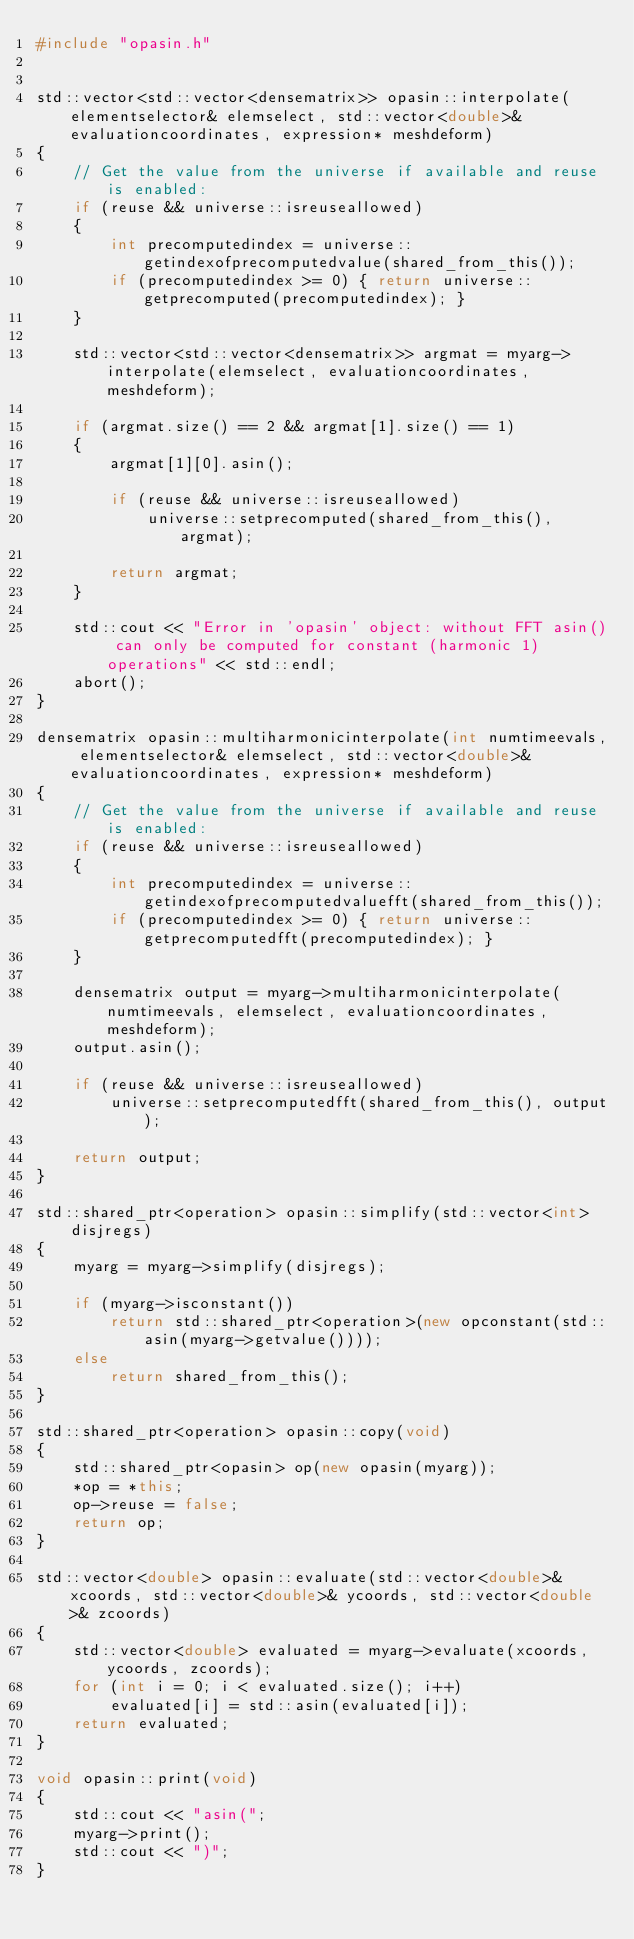Convert code to text. <code><loc_0><loc_0><loc_500><loc_500><_C++_>#include "opasin.h"


std::vector<std::vector<densematrix>> opasin::interpolate(elementselector& elemselect, std::vector<double>& evaluationcoordinates, expression* meshdeform)
{
    // Get the value from the universe if available and reuse is enabled:
    if (reuse && universe::isreuseallowed)
    {
        int precomputedindex = universe::getindexofprecomputedvalue(shared_from_this());
        if (precomputedindex >= 0) { return universe::getprecomputed(precomputedindex); }
    }
    
    std::vector<std::vector<densematrix>> argmat = myarg->interpolate(elemselect, evaluationcoordinates, meshdeform);
    
    if (argmat.size() == 2 && argmat[1].size() == 1)
    {
        argmat[1][0].asin();
        
        if (reuse && universe::isreuseallowed)
            universe::setprecomputed(shared_from_this(), argmat);
        
        return argmat;
    }

    std::cout << "Error in 'opasin' object: without FFT asin() can only be computed for constant (harmonic 1) operations" << std::endl;
    abort();
}

densematrix opasin::multiharmonicinterpolate(int numtimeevals, elementselector& elemselect, std::vector<double>& evaluationcoordinates, expression* meshdeform)
{
    // Get the value from the universe if available and reuse is enabled:
    if (reuse && universe::isreuseallowed)
    {
        int precomputedindex = universe::getindexofprecomputedvaluefft(shared_from_this());
        if (precomputedindex >= 0) { return universe::getprecomputedfft(precomputedindex); }
    }
    
    densematrix output = myarg->multiharmonicinterpolate(numtimeevals, elemselect, evaluationcoordinates, meshdeform);
    output.asin();
            
    if (reuse && universe::isreuseallowed)
        universe::setprecomputedfft(shared_from_this(), output);
    
    return output;
}

std::shared_ptr<operation> opasin::simplify(std::vector<int> disjregs)
{
    myarg = myarg->simplify(disjregs);
    
    if (myarg->isconstant())
        return std::shared_ptr<operation>(new opconstant(std::asin(myarg->getvalue())));
    else
        return shared_from_this();
}

std::shared_ptr<operation> opasin::copy(void)
{
    std::shared_ptr<opasin> op(new opasin(myarg));
    *op = *this;
    op->reuse = false;
    return op;
}

std::vector<double> opasin::evaluate(std::vector<double>& xcoords, std::vector<double>& ycoords, std::vector<double>& zcoords)
{
    std::vector<double> evaluated = myarg->evaluate(xcoords, ycoords, zcoords);
    for (int i = 0; i < evaluated.size(); i++)
        evaluated[i] = std::asin(evaluated[i]);
    return evaluated;
}

void opasin::print(void)
{
    std::cout << "asin(";
    myarg->print();
    std::cout << ")";
}
</code> 